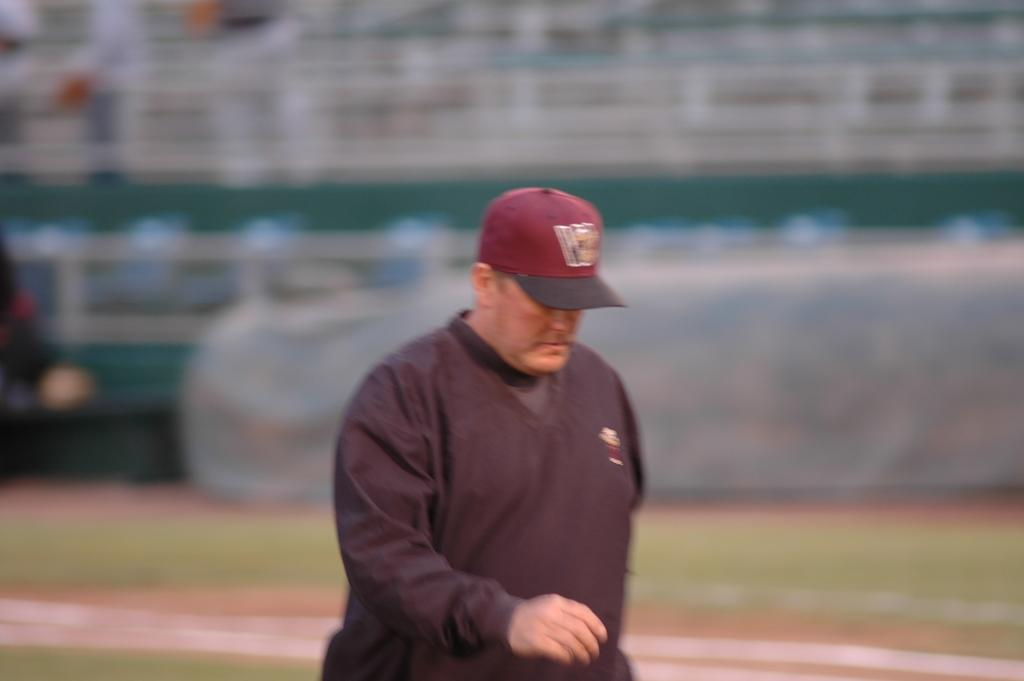Who is present in the image? There is a man in the image. What is the man wearing? The man is wearing a black dress and a red cap. What is the man doing in the image? The man is walking. Can you describe the background of the image? The background of the image is blurry. What type of lumber is the man carrying in the image? There is no lumber present in the image; the man is not carrying anything. 